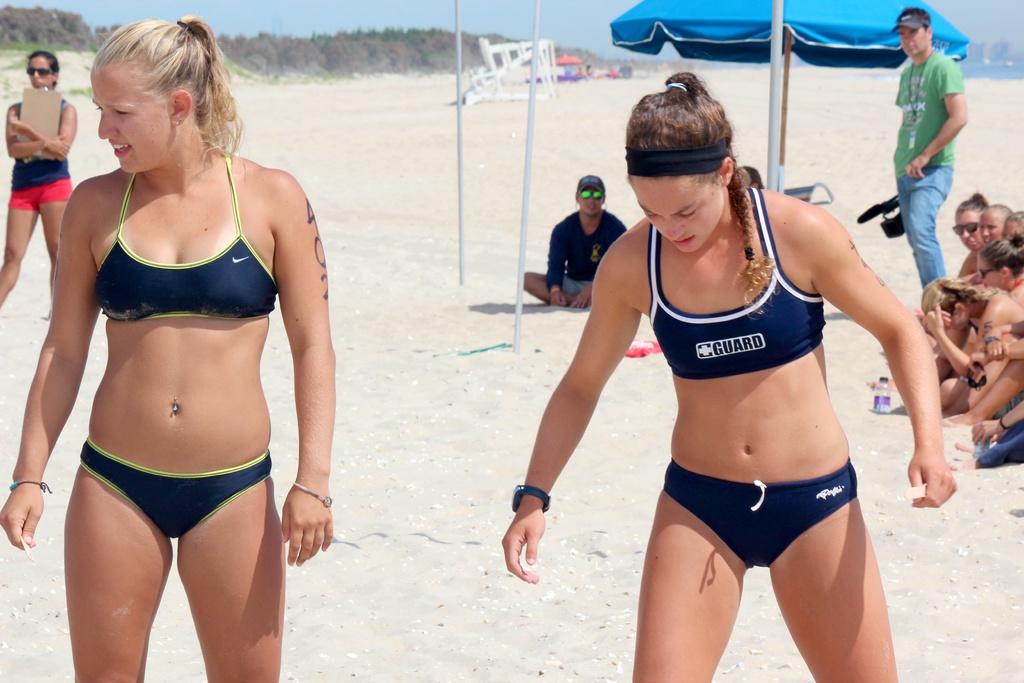What is written on the woman's top on the right?
Give a very brief answer. Guard. What is the last letter on the woman's top on the right?
Make the answer very short. D. 